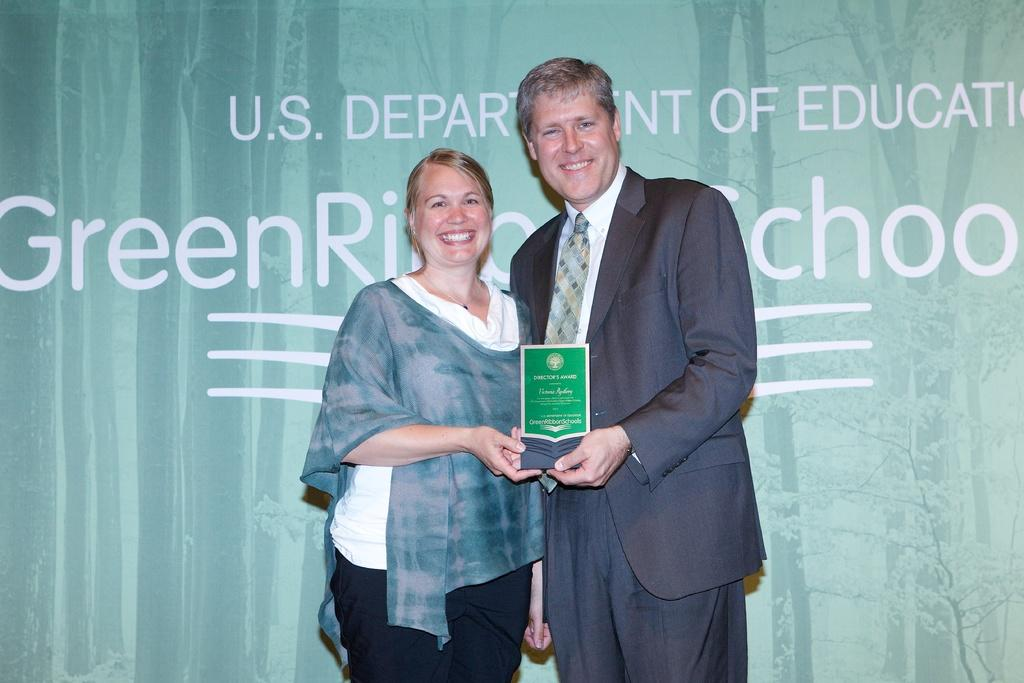Who are the people in the image? There is a lady and a man in the image. What are the lady and the man doing in the image? Both the lady and the man are standing and smiling. What are they holding in the image? They are holding an award. What can be seen in the background of the image? There is a wall in the background of the image. What type of basket is the lady carrying in the image? There is no basket present in the image. Can you tell me how many dinosaurs are visible in the image? There are no dinosaurs present in the image. 